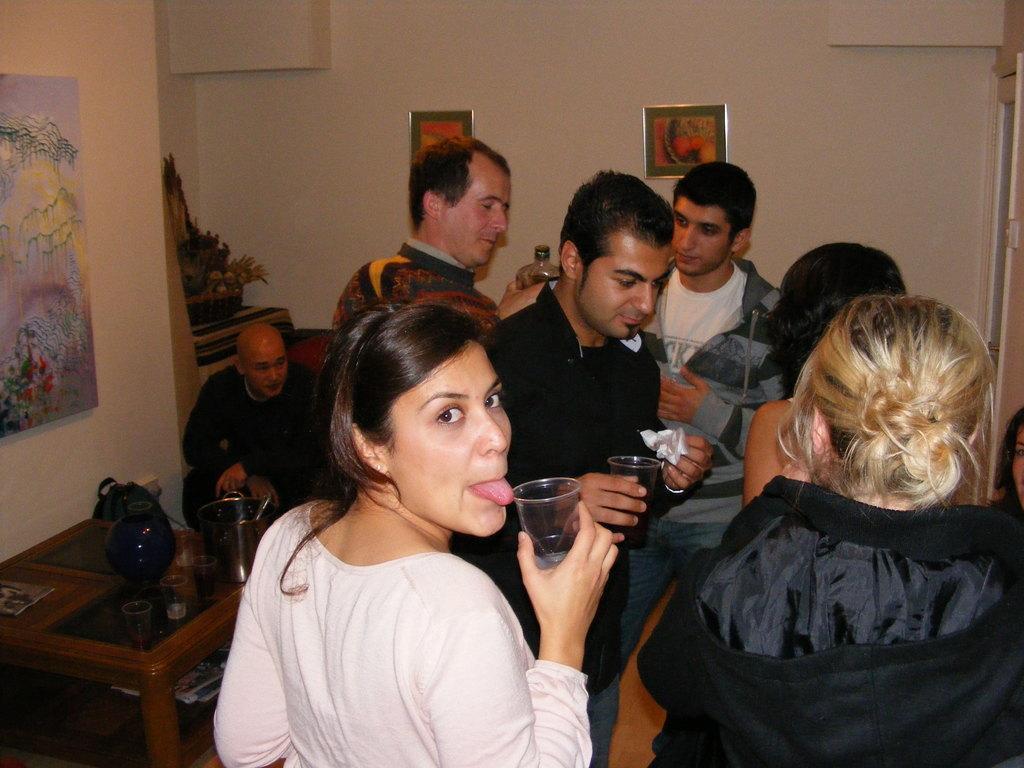Please provide a concise description of this image. This picture is clicked inside the room. Here, we see six people standing and they are holding the glasses in their hands. Beside them, we see a man in black jacket is sitting. In front of him, we see a table on which water bottle, black bag and book are placed. Beside that, we see a wall on which photo frame is placed. In the background, we see a flower pot and a white wall on which photo frames are placed. 